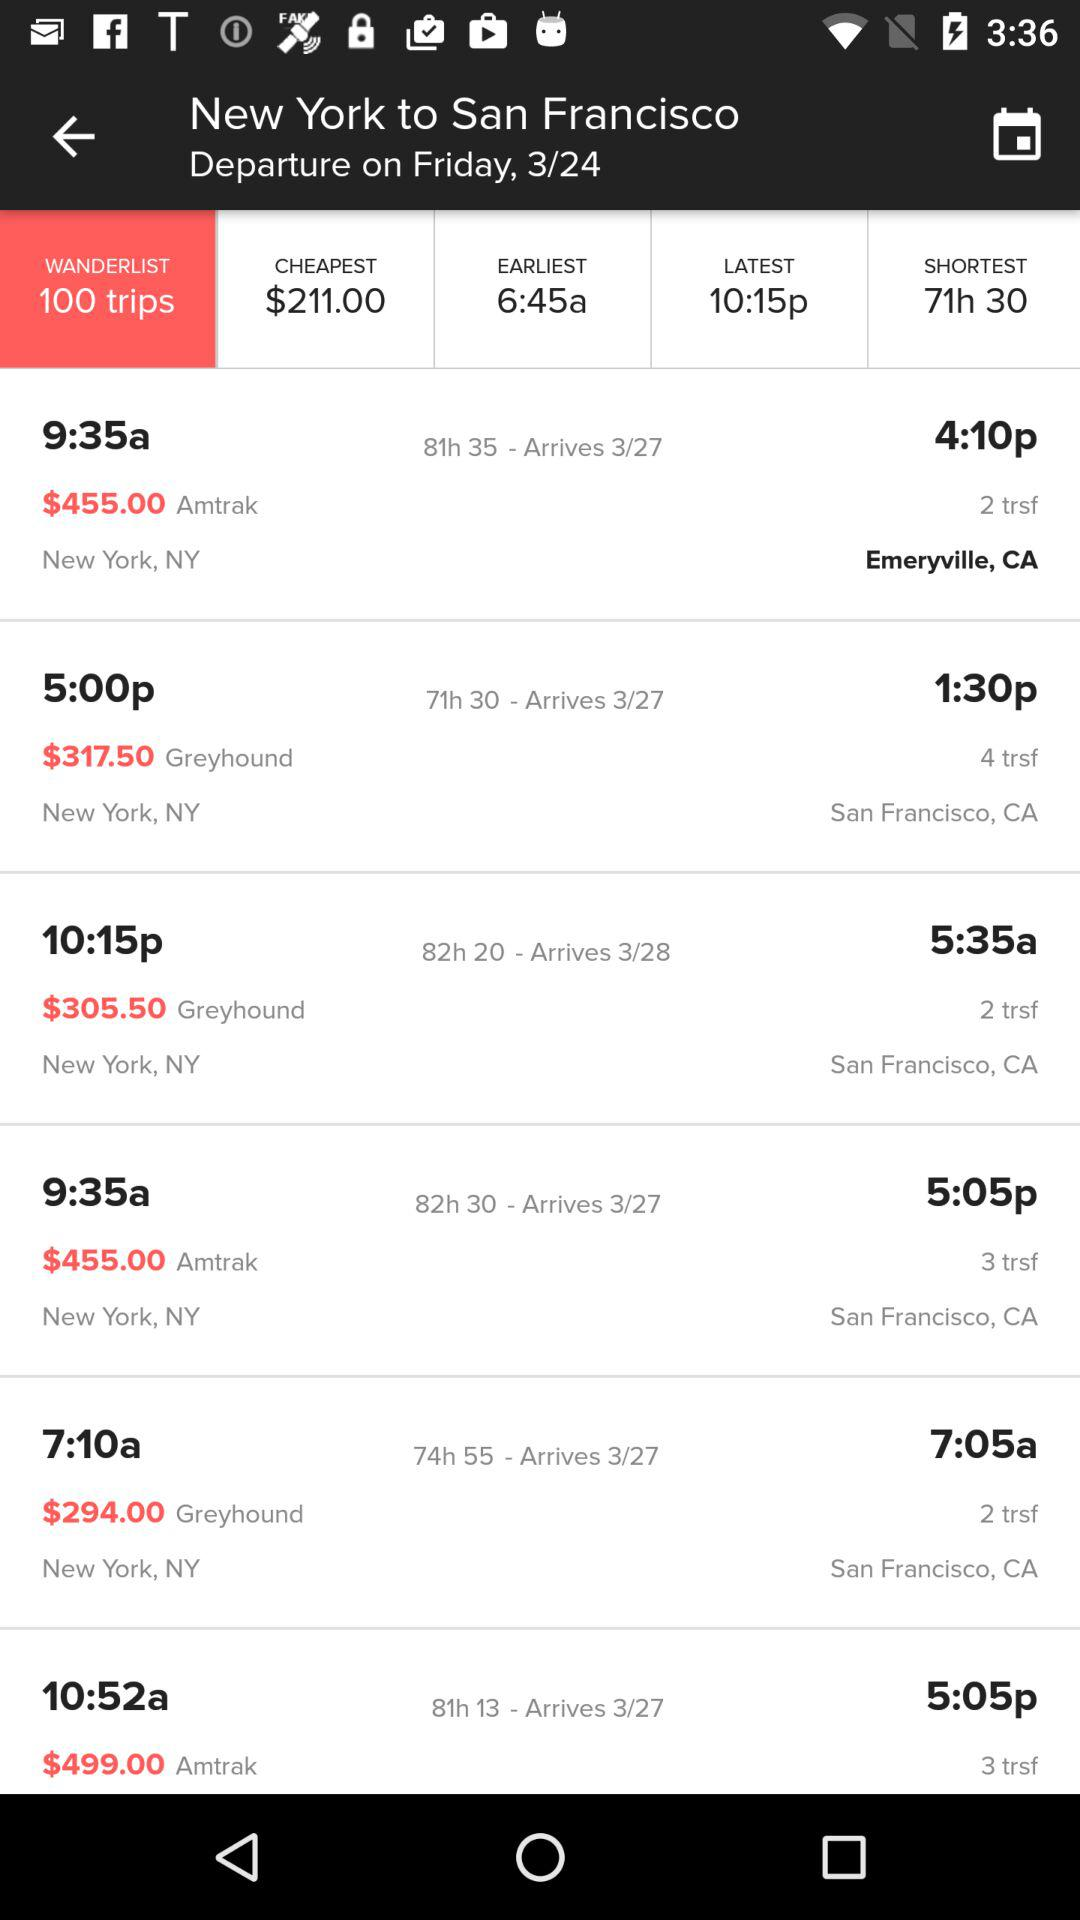What is the cheapest flight fare? The cheapest flight fare is $211.00. 